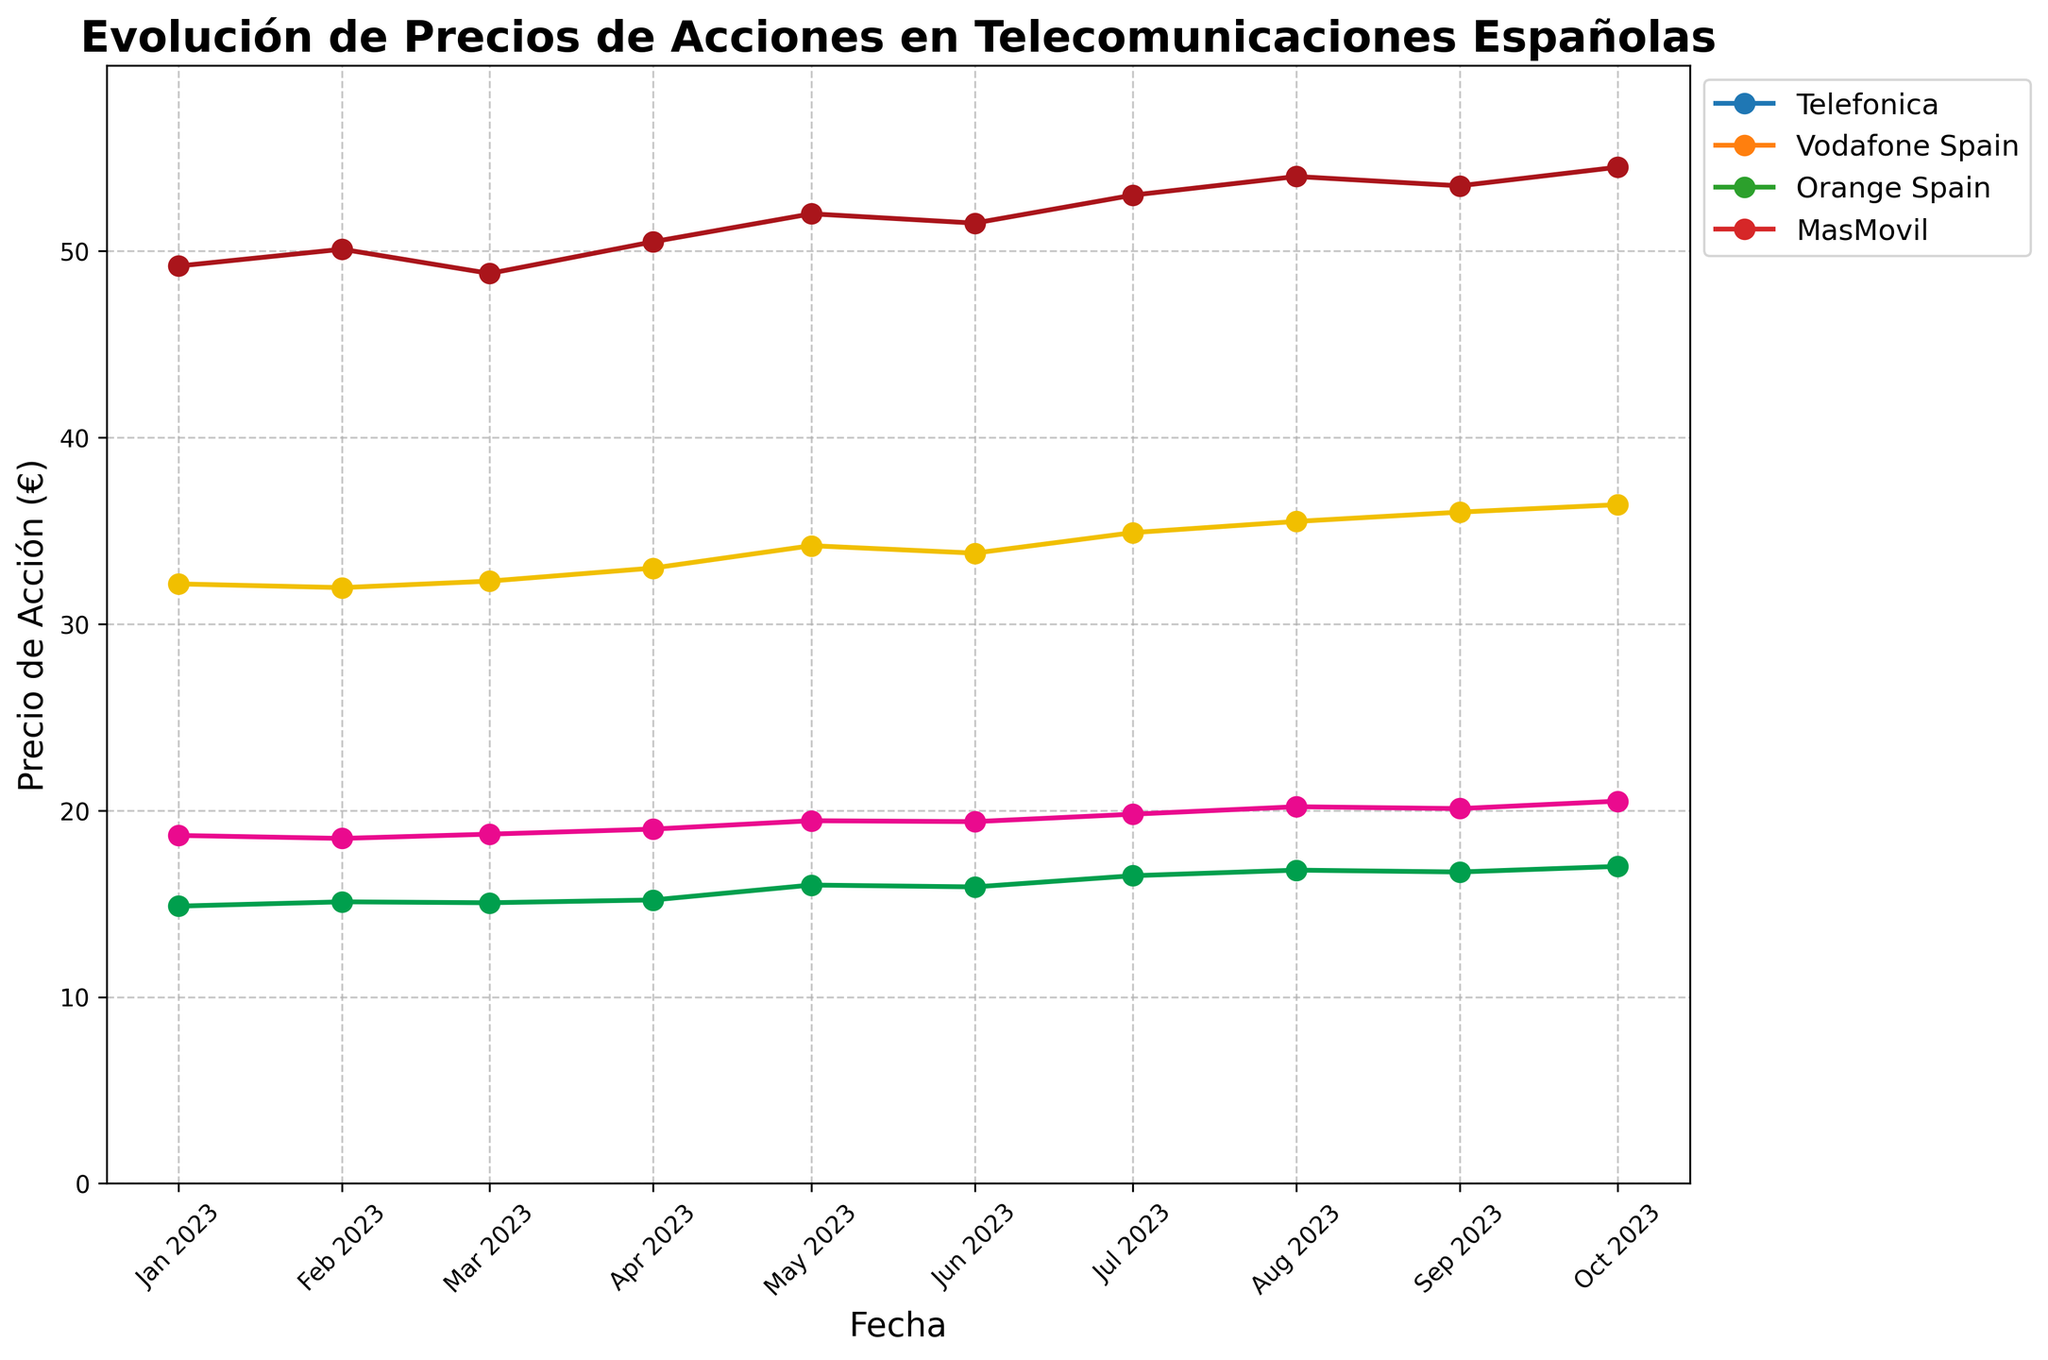What's the title of the plot? The title of the plot is displayed at the top in bold. It provides a summary of what the figure represents.
Answer: Evolución de Precios de Acciones en Telecomunicaciones Españolas What is the highest stock price for Telefonica and when did it occur? Look for the peak point in the Telefonica data line, then check the corresponding date on the x-axis. Telefonica reaches its highest price of 54.50 € on October 1, 2023.
Answer: 54.50 € on October 1, 2023 Between which months did Orange Spain see the most significant increase in stock price? Observe the changes in Orange Spain's stock price month by month. Identify the highest increase by comparing each month's value to the previous month. The major increase occurred between July and August 2023.
Answer: July and August 2023 What are the different colors used in the plot and which company does each color represent? The colors can be distinguished by looking at the lines in the figure. The legend on the right side assigns each color to a company.
Answer: Red for Telefonica, Yellow for Vodafone Spain, Pink for Orange Spain, Green for MasMovil Which company had the most stable stock price over the observed period? Evaluate the fluctuation patterns of each company's stock prices by observing the smoothness of their corresponding lines. The company with the least fluctuation is Orange Spain.
Answer: Orange Spain Which company showed the highest increase in stock price from January to October 2023, and by how much did it increase? Calculate the difference between the stock prices in January and October for each company, and identify the highest difference. Vodafone Spain increased from 32.15 € to 36.40 €, a total increase of 4.25 €.
Answer: Vodafone Spain, 4.25 € On average, what was the stock price of MasMovil over the observed months? Add all the monthly stock prices of MasMovil and divide by the number of months (10). The sum is 148.12 €, so the average is 148.12 €/10.
Answer: 14.81 € In which month did Vodafone Spain's stock price surpass that of Telefonica for the first time, if at all? Compare the monthly prices of Vodafone Spain and Telefonica to determine if and when Vodafone Spain's price became higher. Vodafone Spain never surpassed Telefonica in the observed period.
Answer: It did not happen How many data points are there for each company in the plot? Count the number of data points (months) for each company by looking at the x-axis or the plotted points. There are 10 data points for each company.
Answer: 10 What is the average change in Telefonica's stock price per month from January to October? Subtract Telefonica's price in January from its price in October, then divide by the number of months minus one (10 - 1). The change is (54.50 € - 49.20 €)/9 months.
Answer: 0.59 €/month 